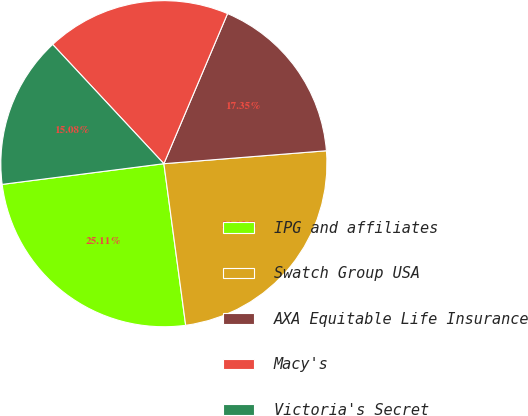Convert chart. <chart><loc_0><loc_0><loc_500><loc_500><pie_chart><fcel>IPG and affiliates<fcel>Swatch Group USA<fcel>AXA Equitable Life Insurance<fcel>Macy's<fcel>Victoria's Secret<nl><fcel>25.11%<fcel>24.13%<fcel>17.35%<fcel>18.33%<fcel>15.08%<nl></chart> 